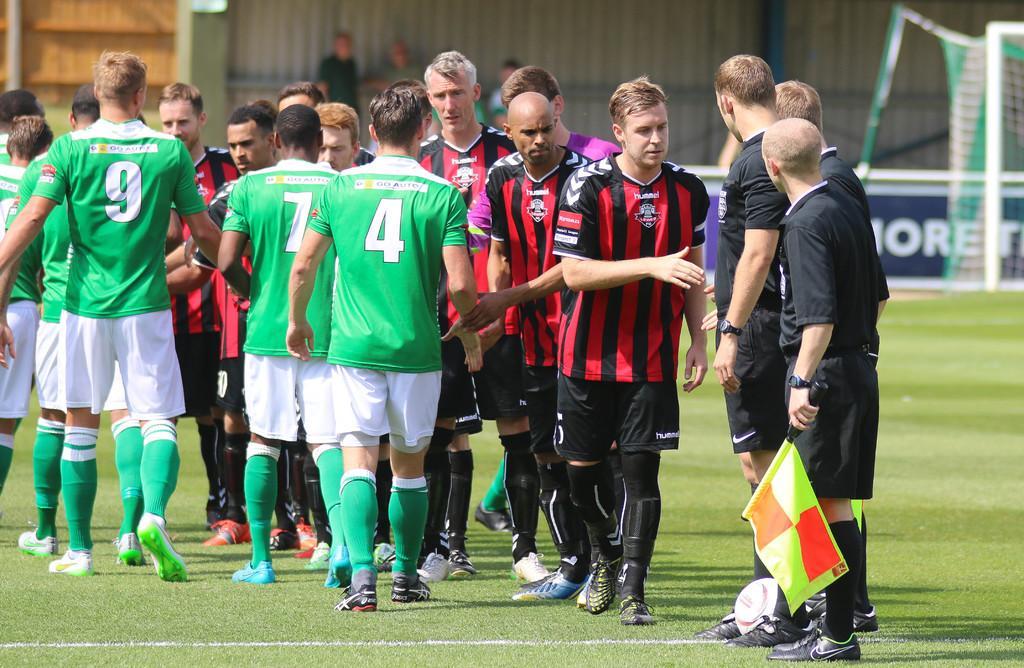Could you give a brief overview of what you see in this image? In this image I can see an open gross ground and on it I can see number of people are standing. I can see few of them are wearing green colour dress, few are wearing red and rest all are wearing black colour dress. On the right side of this image I can see a man is holding a flag and near his leg I can see a white colour football. In the background I can see a board, a goal post and I can see this image is little bit blurry in the background. 